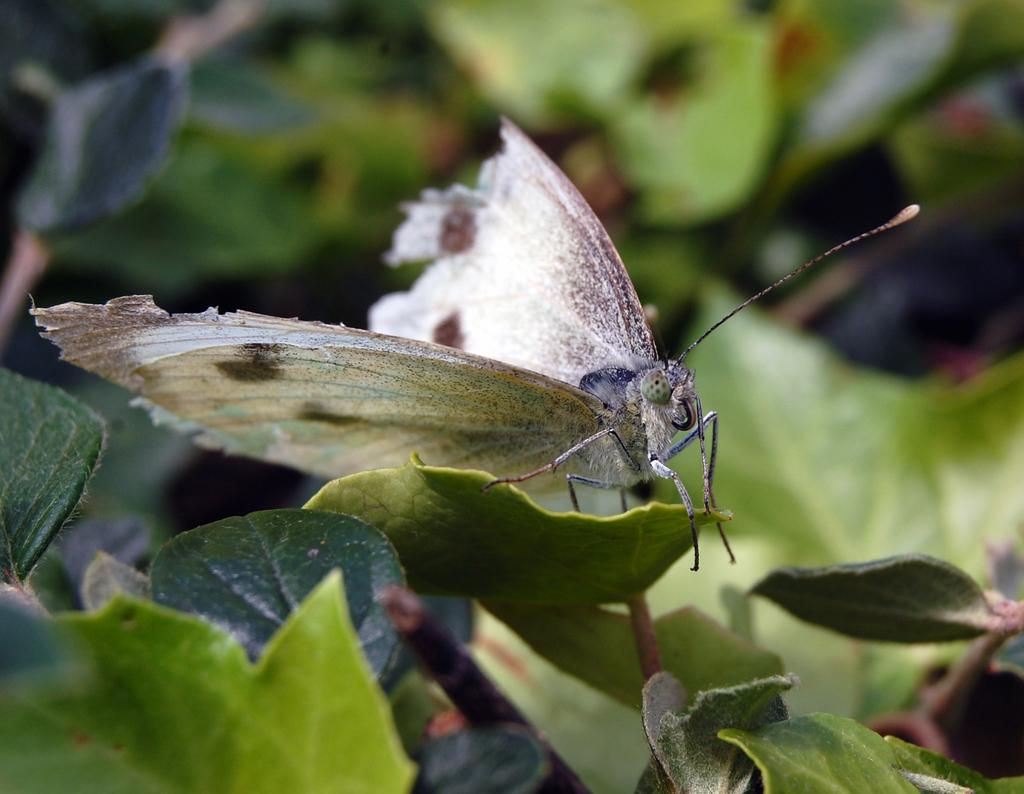What is the main subject of the image? There is a small butterfly in the image. What is the butterfly doing in the image? The butterfly is laying on a leaf. Can you describe the leaf in the image? The leaf is part of a plant. What color is the background of the butterfly? The background of the butterfly is blue. What type of breakfast is the butterfly eating in the image? There is no breakfast present in the image, as it features a butterfly laying on a leaf. Can you tell me what kind of shoe the butterfly is wearing in the image? There is no shoe present in the image, as it features a butterfly laying on a leaf. 